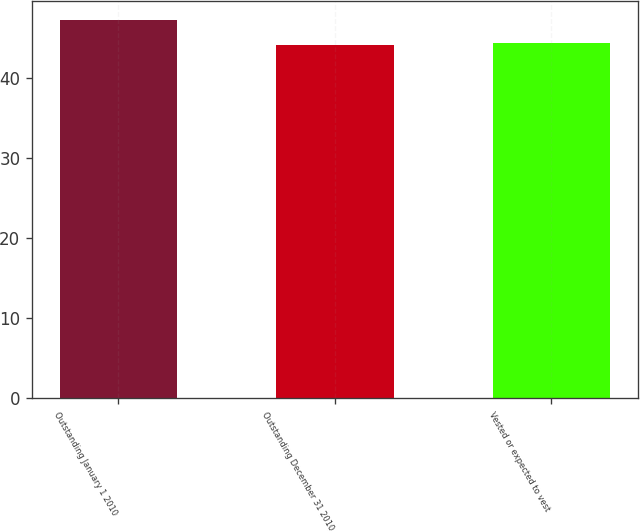<chart> <loc_0><loc_0><loc_500><loc_500><bar_chart><fcel>Outstanding January 1 2010<fcel>Outstanding December 31 2010<fcel>Vested or expected to vest<nl><fcel>47.15<fcel>44.03<fcel>44.34<nl></chart> 